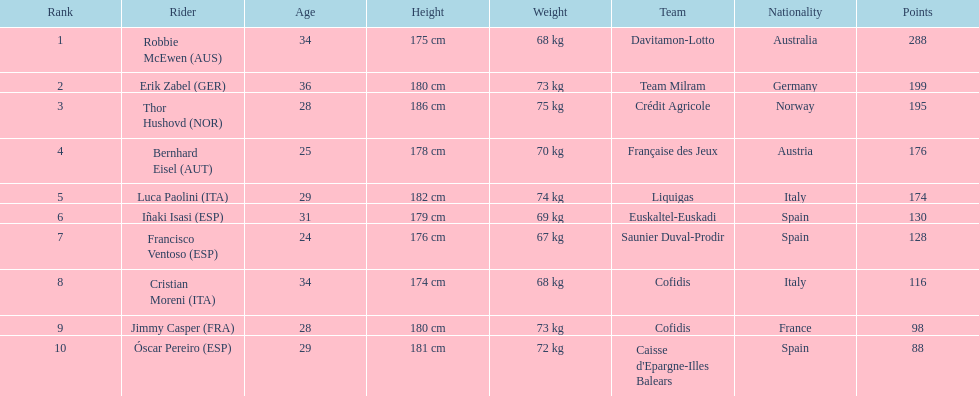How many points did robbie mcewen and cristian moreni score together? 404. 